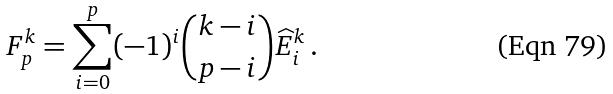Convert formula to latex. <formula><loc_0><loc_0><loc_500><loc_500>F _ { p } ^ { k } = \sum _ { i = 0 } ^ { p } ( - 1 ) ^ { i } \binom { k - i } { p - i } \widehat { E } _ { i } ^ { k } \, .</formula> 